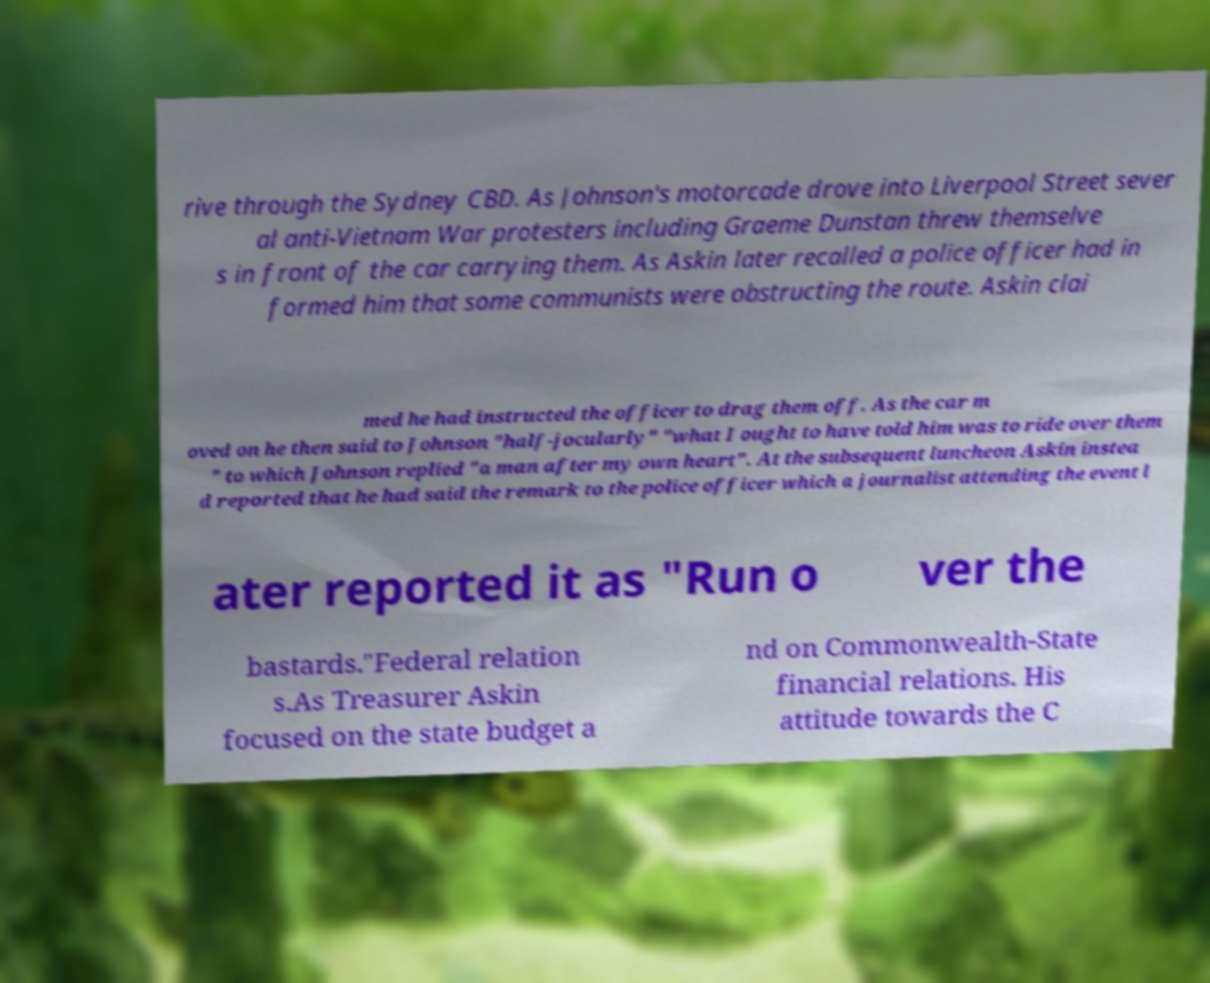There's text embedded in this image that I need extracted. Can you transcribe it verbatim? rive through the Sydney CBD. As Johnson's motorcade drove into Liverpool Street sever al anti-Vietnam War protesters including Graeme Dunstan threw themselve s in front of the car carrying them. As Askin later recalled a police officer had in formed him that some communists were obstructing the route. Askin clai med he had instructed the officer to drag them off. As the car m oved on he then said to Johnson "half-jocularly" "what I ought to have told him was to ride over them " to which Johnson replied "a man after my own heart". At the subsequent luncheon Askin instea d reported that he had said the remark to the police officer which a journalist attending the event l ater reported it as "Run o ver the bastards."Federal relation s.As Treasurer Askin focused on the state budget a nd on Commonwealth-State financial relations. His attitude towards the C 